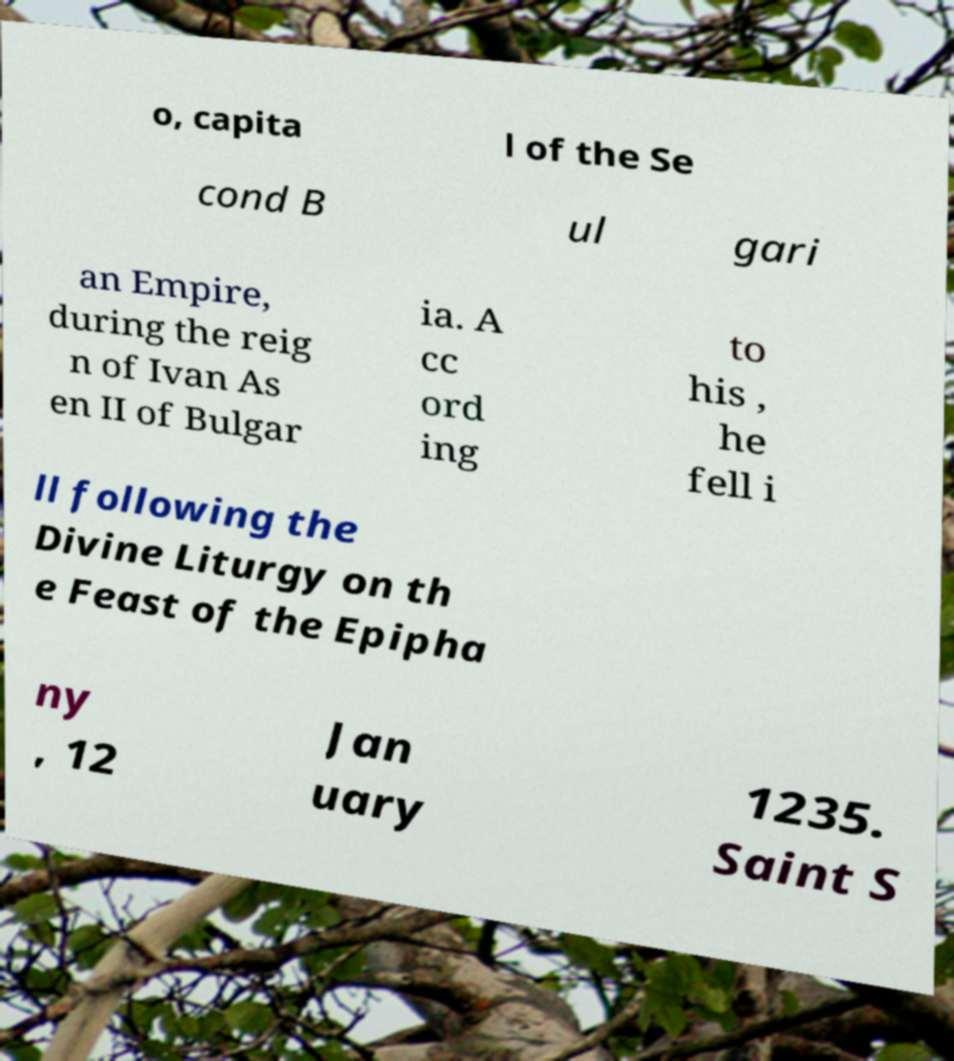There's text embedded in this image that I need extracted. Can you transcribe it verbatim? o, capita l of the Se cond B ul gari an Empire, during the reig n of Ivan As en II of Bulgar ia. A cc ord ing to his , he fell i ll following the Divine Liturgy on th e Feast of the Epipha ny , 12 Jan uary 1235. Saint S 